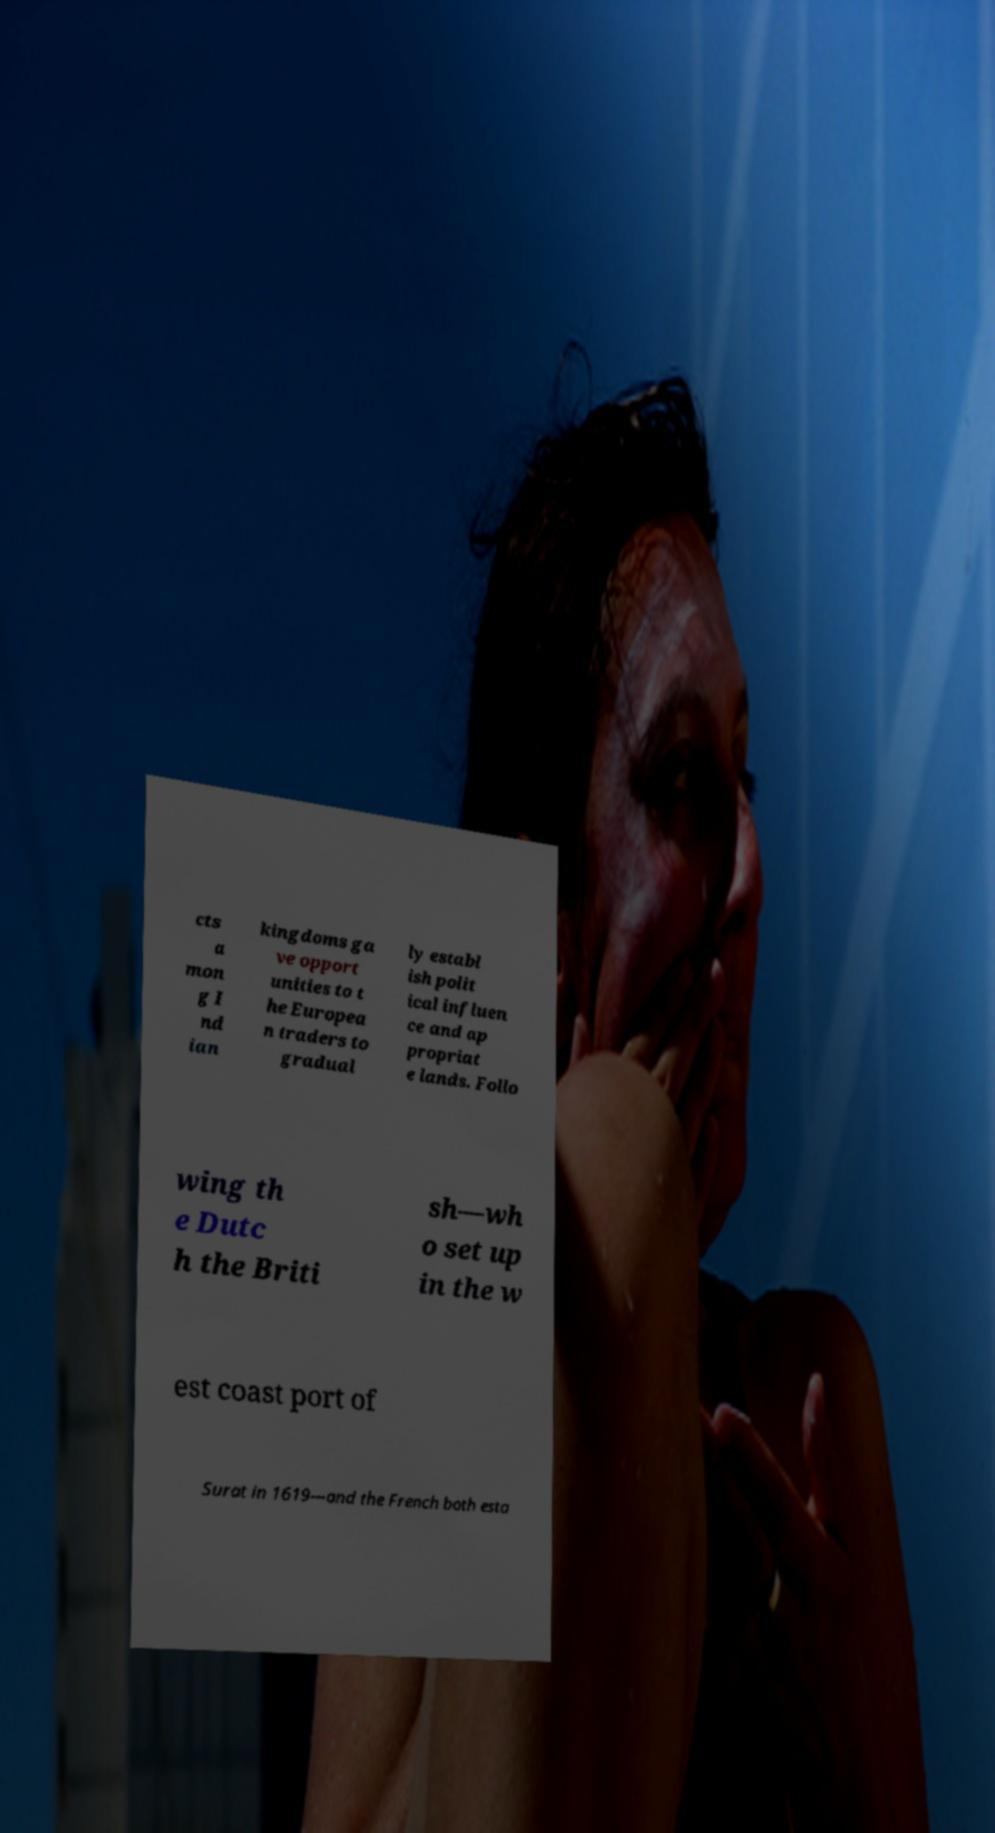There's text embedded in this image that I need extracted. Can you transcribe it verbatim? cts a mon g I nd ian kingdoms ga ve opport unities to t he Europea n traders to gradual ly establ ish polit ical influen ce and ap propriat e lands. Follo wing th e Dutc h the Briti sh—wh o set up in the w est coast port of Surat in 1619—and the French both esta 